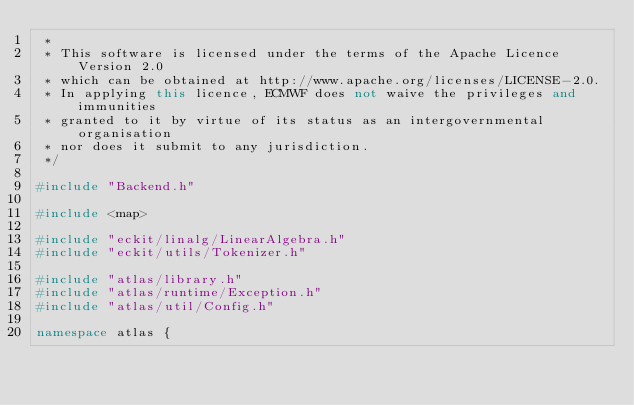<code> <loc_0><loc_0><loc_500><loc_500><_C++_> *
 * This software is licensed under the terms of the Apache Licence Version 2.0
 * which can be obtained at http://www.apache.org/licenses/LICENSE-2.0.
 * In applying this licence, ECMWF does not waive the privileges and immunities
 * granted to it by virtue of its status as an intergovernmental organisation
 * nor does it submit to any jurisdiction.
 */

#include "Backend.h"

#include <map>

#include "eckit/linalg/LinearAlgebra.h"
#include "eckit/utils/Tokenizer.h"

#include "atlas/library.h"
#include "atlas/runtime/Exception.h"
#include "atlas/util/Config.h"

namespace atlas {</code> 